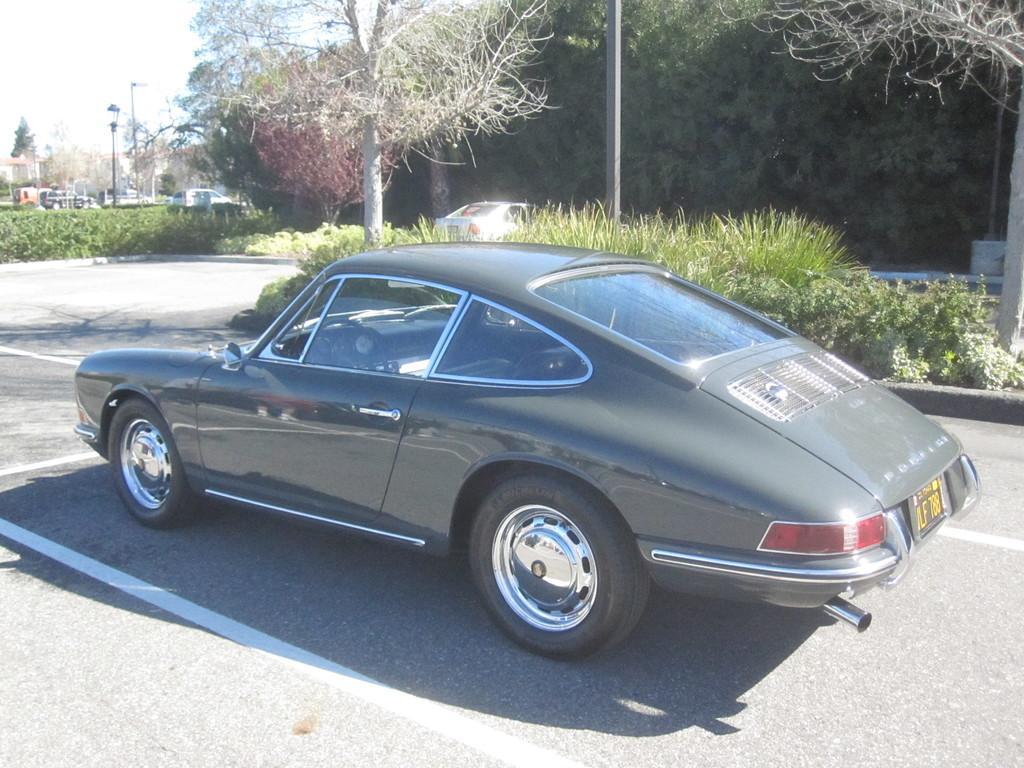In one or two sentences, can you explain what this image depicts? In this picture there is a car in the center of the image and there are trees and other cars in the background area of the image. 